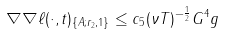<formula> <loc_0><loc_0><loc_500><loc_500>\| \nabla \nabla \ell ( \cdot , t ) \| _ { \{ A ; r _ { 2 } , 1 \} } \leq c _ { 5 } ( \nu T ) ^ { - \frac { 1 } { 2 } } G ^ { 4 } g</formula> 